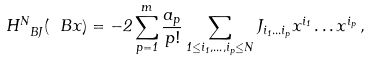<formula> <loc_0><loc_0><loc_500><loc_500>H ^ { N } _ { \ B J } ( \ B x ) = - 2 \sum _ { p = 1 } ^ { m } \frac { a _ { p } } { p ! } \sum _ { 1 \leq i _ { 1 } , \dots , i _ { p } \leq N } J _ { i _ { 1 } \dots i _ { p } } x ^ { i _ { 1 } } \dots x ^ { i _ { p } } \, ,</formula> 